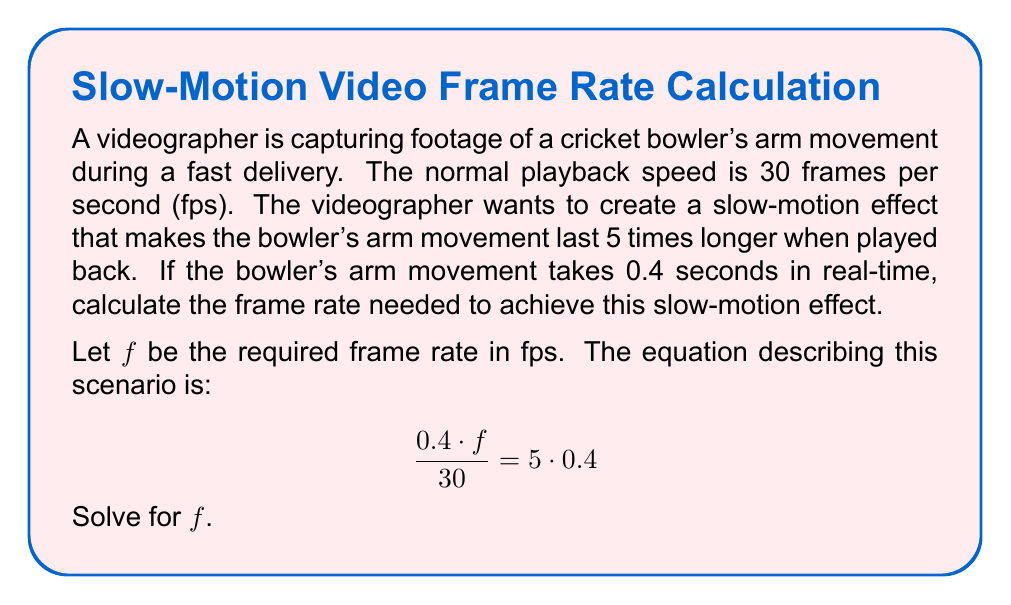Can you answer this question? Let's solve this problem step by step:

1) We start with the given equation:

   $$\frac{0.4 \cdot f}{30} = 5 \cdot 0.4$$

2) First, let's simplify the right side of the equation:

   $$\frac{0.4 \cdot f}{30} = 2$$

3) Now, we can multiply both sides by 30 to isolate the term with $f$:

   $$0.4 \cdot f = 2 \cdot 30$$

4) Simplify the right side:

   $$0.4 \cdot f = 60$$

5) Finally, divide both sides by 0.4 to solve for $f$:

   $$f = \frac{60}{0.4} = 150$$

Therefore, the required frame rate is 150 fps.

To verify:
- At 150 fps, 0.4 seconds of real-time footage will contain $0.4 \cdot 150 = 60$ frames.
- When played back at 30 fps, these 60 frames will take $60 / 30 = 2$ seconds.
- This is indeed 5 times longer than the original 0.4 seconds.
Answer: 150 fps 